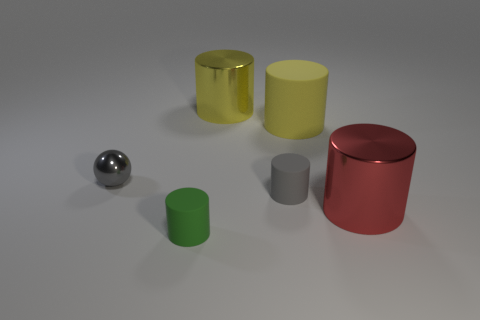What number of things are either blue balls or cylinders that are to the left of the big yellow metal cylinder?
Make the answer very short. 1. Do the rubber thing in front of the red metal cylinder and the big metal thing that is in front of the gray matte object have the same shape?
Keep it short and to the point. Yes. What number of objects are small purple matte spheres or matte things?
Your answer should be very brief. 3. Is there any other thing that is the same material as the red object?
Your response must be concise. Yes. Is there a big matte object?
Provide a succinct answer. Yes. Is the gray thing that is in front of the gray sphere made of the same material as the red object?
Your answer should be very brief. No. Is there a gray rubber thing that has the same shape as the large red object?
Provide a short and direct response. Yes. Are there the same number of yellow metallic cylinders that are in front of the green rubber thing and green rubber objects?
Ensure brevity in your answer.  No. The gray object left of the cylinder in front of the big red metal object is made of what material?
Provide a succinct answer. Metal. The yellow metallic thing is what shape?
Offer a terse response. Cylinder. 